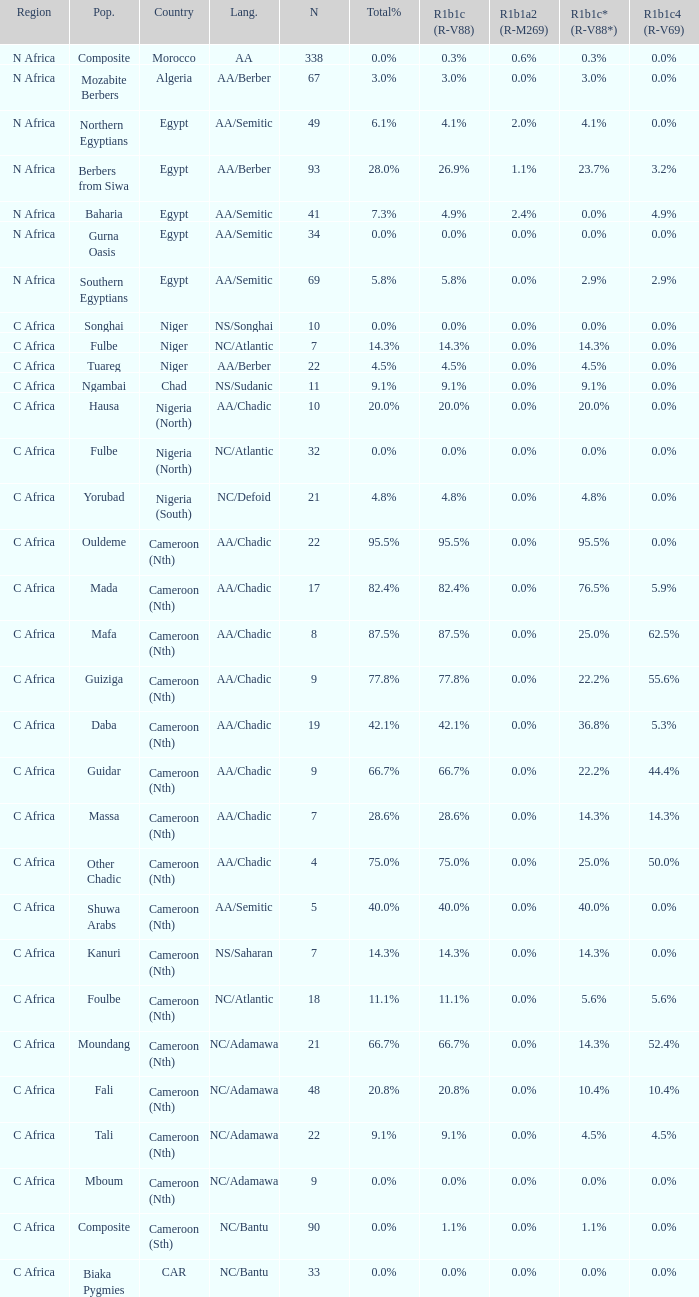What percentage is listed in column r1b1a2 (r-m269) for the 77.8% r1b1c (r-v88)? 0.0%. 